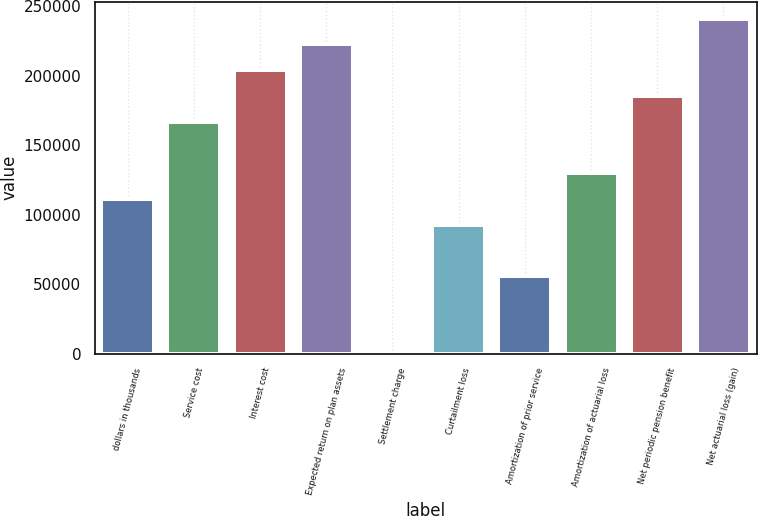<chart> <loc_0><loc_0><loc_500><loc_500><bar_chart><fcel>dollars in thousands<fcel>Service cost<fcel>Interest cost<fcel>Expected return on plan assets<fcel>Settlement charge<fcel>Curtailment loss<fcel>Amortization of prior service<fcel>Amortization of actuarial loss<fcel>Net periodic pension benefit<fcel>Net actuarial loss (gain)<nl><fcel>111248<fcel>166870<fcel>203952<fcel>222493<fcel>2.82<fcel>92706.9<fcel>55625.3<fcel>129789<fcel>185411<fcel>241033<nl></chart> 